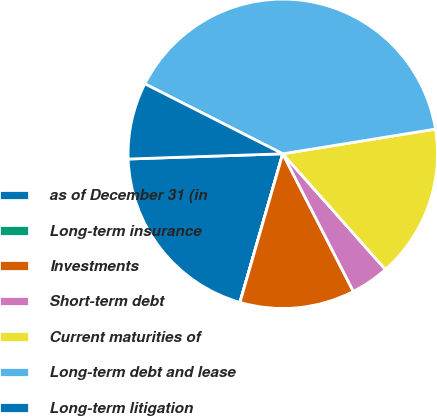Convert chart to OTSL. <chart><loc_0><loc_0><loc_500><loc_500><pie_chart><fcel>as of December 31 (in<fcel>Long-term insurance<fcel>Investments<fcel>Short-term debt<fcel>Current maturities of<fcel>Long-term debt and lease<fcel>Long-term litigation<nl><fcel>19.99%<fcel>0.01%<fcel>12.0%<fcel>4.01%<fcel>16.0%<fcel>39.97%<fcel>8.01%<nl></chart> 